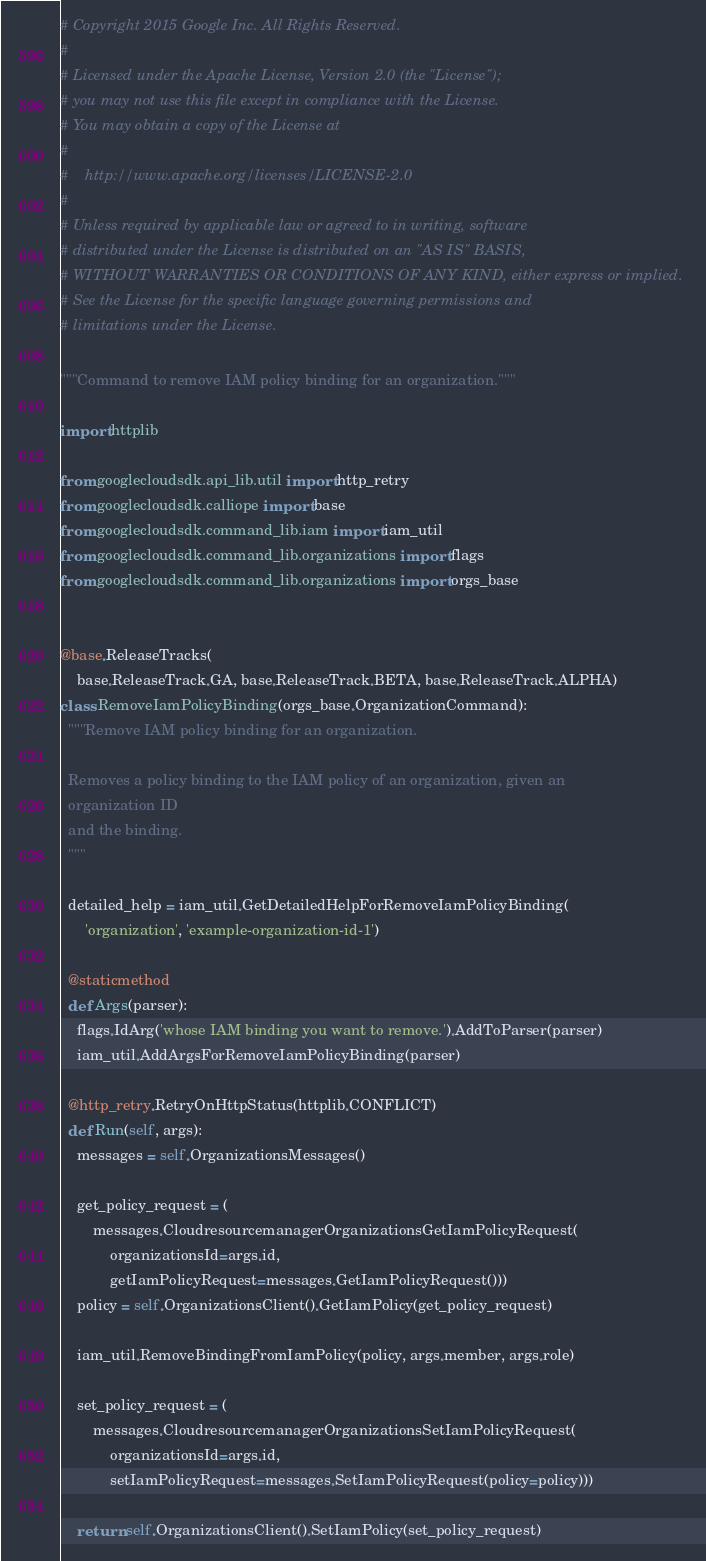Convert code to text. <code><loc_0><loc_0><loc_500><loc_500><_Python_># Copyright 2015 Google Inc. All Rights Reserved.
#
# Licensed under the Apache License, Version 2.0 (the "License");
# you may not use this file except in compliance with the License.
# You may obtain a copy of the License at
#
#    http://www.apache.org/licenses/LICENSE-2.0
#
# Unless required by applicable law or agreed to in writing, software
# distributed under the License is distributed on an "AS IS" BASIS,
# WITHOUT WARRANTIES OR CONDITIONS OF ANY KIND, either express or implied.
# See the License for the specific language governing permissions and
# limitations under the License.

"""Command to remove IAM policy binding for an organization."""

import httplib

from googlecloudsdk.api_lib.util import http_retry
from googlecloudsdk.calliope import base
from googlecloudsdk.command_lib.iam import iam_util
from googlecloudsdk.command_lib.organizations import flags
from googlecloudsdk.command_lib.organizations import orgs_base


@base.ReleaseTracks(
    base.ReleaseTrack.GA, base.ReleaseTrack.BETA, base.ReleaseTrack.ALPHA)
class RemoveIamPolicyBinding(orgs_base.OrganizationCommand):
  """Remove IAM policy binding for an organization.

  Removes a policy binding to the IAM policy of an organization, given an
  organization ID
  and the binding.
  """

  detailed_help = iam_util.GetDetailedHelpForRemoveIamPolicyBinding(
      'organization', 'example-organization-id-1')

  @staticmethod
  def Args(parser):
    flags.IdArg('whose IAM binding you want to remove.').AddToParser(parser)
    iam_util.AddArgsForRemoveIamPolicyBinding(parser)

  @http_retry.RetryOnHttpStatus(httplib.CONFLICT)
  def Run(self, args):
    messages = self.OrganizationsMessages()

    get_policy_request = (
        messages.CloudresourcemanagerOrganizationsGetIamPolicyRequest(
            organizationsId=args.id,
            getIamPolicyRequest=messages.GetIamPolicyRequest()))
    policy = self.OrganizationsClient().GetIamPolicy(get_policy_request)

    iam_util.RemoveBindingFromIamPolicy(policy, args.member, args.role)

    set_policy_request = (
        messages.CloudresourcemanagerOrganizationsSetIamPolicyRequest(
            organizationsId=args.id,
            setIamPolicyRequest=messages.SetIamPolicyRequest(policy=policy)))

    return self.OrganizationsClient().SetIamPolicy(set_policy_request)
</code> 